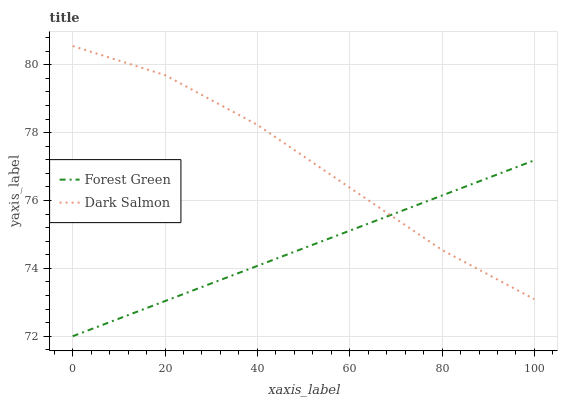Does Forest Green have the minimum area under the curve?
Answer yes or no. Yes. Does Dark Salmon have the maximum area under the curve?
Answer yes or no. Yes. Does Dark Salmon have the minimum area under the curve?
Answer yes or no. No. Is Forest Green the smoothest?
Answer yes or no. Yes. Is Dark Salmon the roughest?
Answer yes or no. Yes. Is Dark Salmon the smoothest?
Answer yes or no. No. Does Forest Green have the lowest value?
Answer yes or no. Yes. Does Dark Salmon have the lowest value?
Answer yes or no. No. Does Dark Salmon have the highest value?
Answer yes or no. Yes. Does Dark Salmon intersect Forest Green?
Answer yes or no. Yes. Is Dark Salmon less than Forest Green?
Answer yes or no. No. Is Dark Salmon greater than Forest Green?
Answer yes or no. No. 